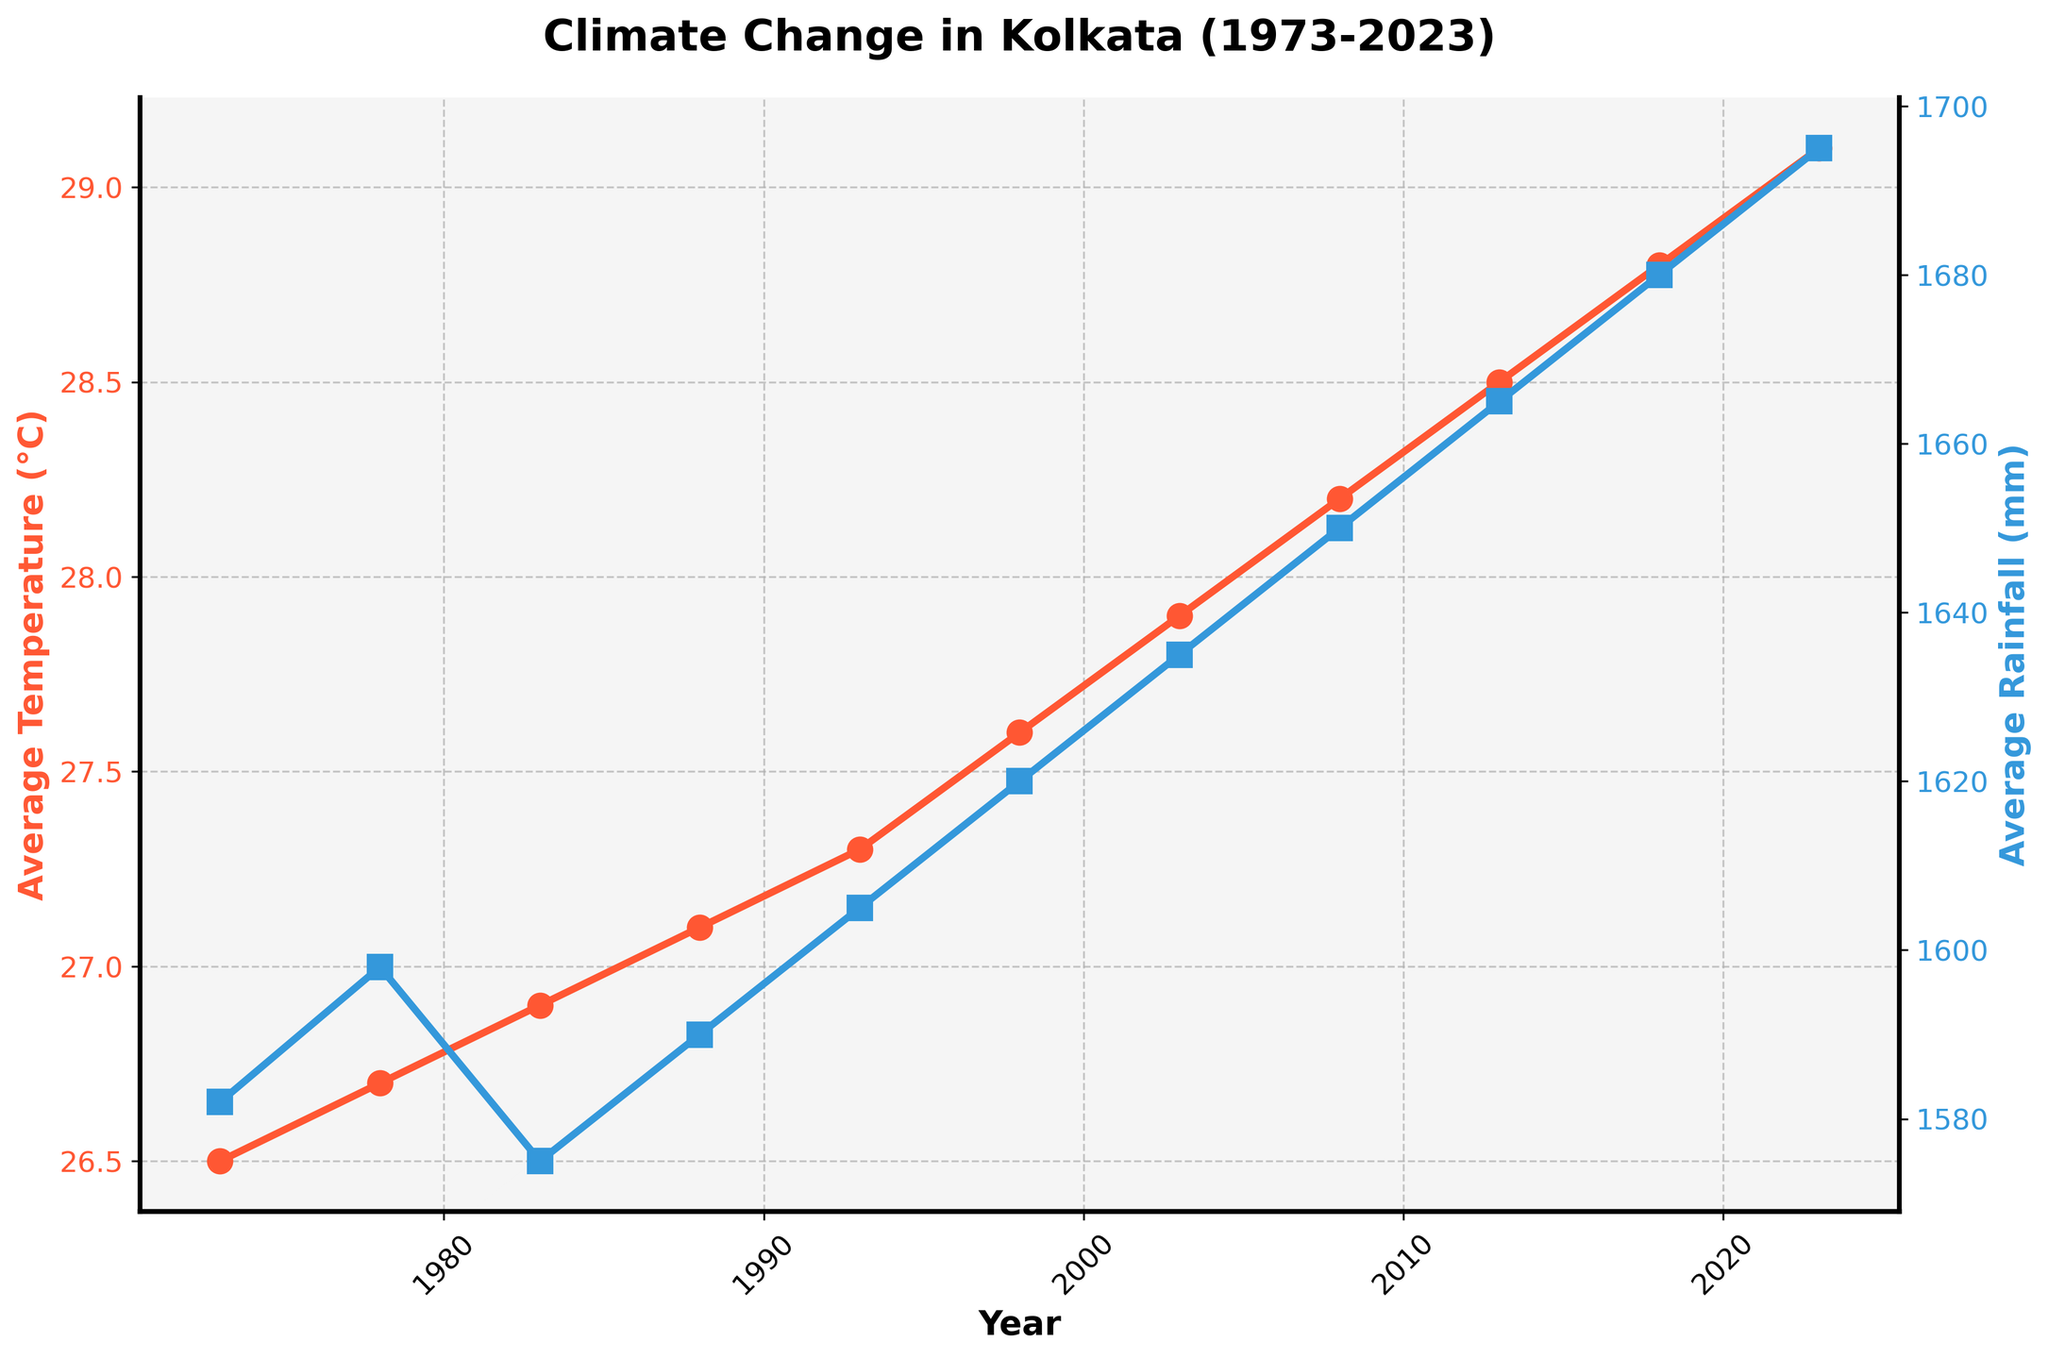What's the increase in average temperature from 1973 to 2023? First, note the average temperature in 1973 is 26.5°C and in 2023 is 29.1°C. Calculate the difference: 29.1 - 26.5 = 2.6°C.
Answer: 2.6°C What was the average temperature in 1998? Refer to the figure where the temperature for the year 1998 is marked; it shows 27.6°C.
Answer: 27.6°C In which year was the average rainfall the highest? Look for the year where the blue line (rainfall) peaks. The highest point on the blue line occurs in 2023, with 1695 mm of rainfall.
Answer: 2023 How does the average rainfall trend from 1973 to 2023? Observe the blue line indicating rainfall; it steadily increases from 1582 mm in 1973 to 1695 mm in 2023.
Answer: Increasing trend Which year had the greatest increase in average temperature compared to its previous data point? Examine the temperature line and compare the year-to-year increases: the difference between 28.8°C in 2018 and 29.1°C in 2023 is 0.3°C, which is the greatest increase.
Answer: 2018 to 2023 What is the difference in average rainfall between 1983 and 2003? Find the rainfall in 1983 (1575 mm) and in 2003 (1635 mm), then compute the difference: 1635 - 1575 = 60 mm.
Answer: 60 mm Does the average temperature ever decrease from one recorded year to the next? The figure shows a continuous increase in average temperature from 1973 to 2023 without any decreases.
Answer: No By how much has the average rainfall changed from 1998 to 2013? Note the rainfall for 1998 (1620 mm) and 2013 (1665 mm). Calculate the change: 1665 - 1620 = 45 mm.
Answer: 45 mm What is the average temperature for the first and last decade combined (1973-1983 and 2013-2023)? Calculate the average of [(26.5 + 26.7 + 26.9) + (28.5 + 28.8 + 29.1)] / 6. Sum is (81.1) / 6 = 27.7°C.
Answer: 27.7°C 